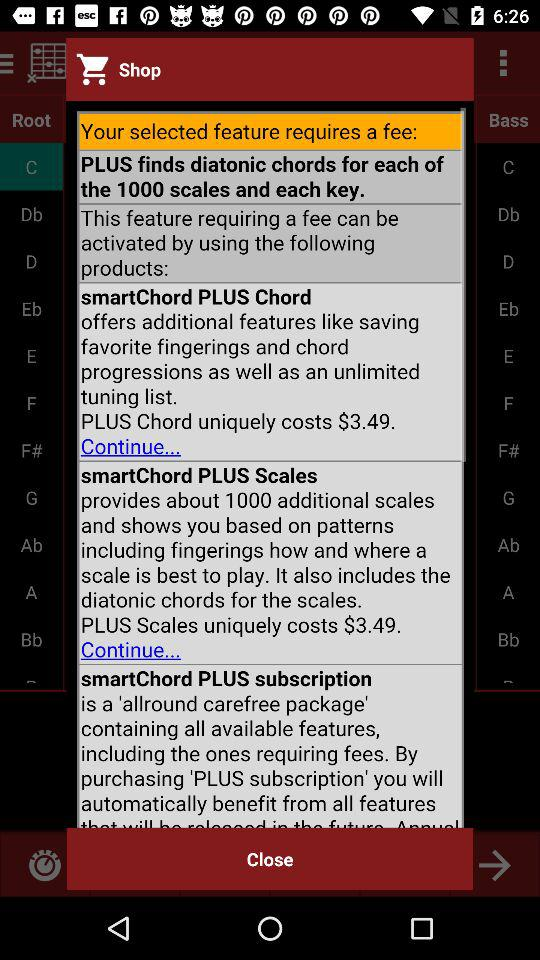What is the cost of "PLUS Chord"? "PLUS Chord" costs $3.49. 